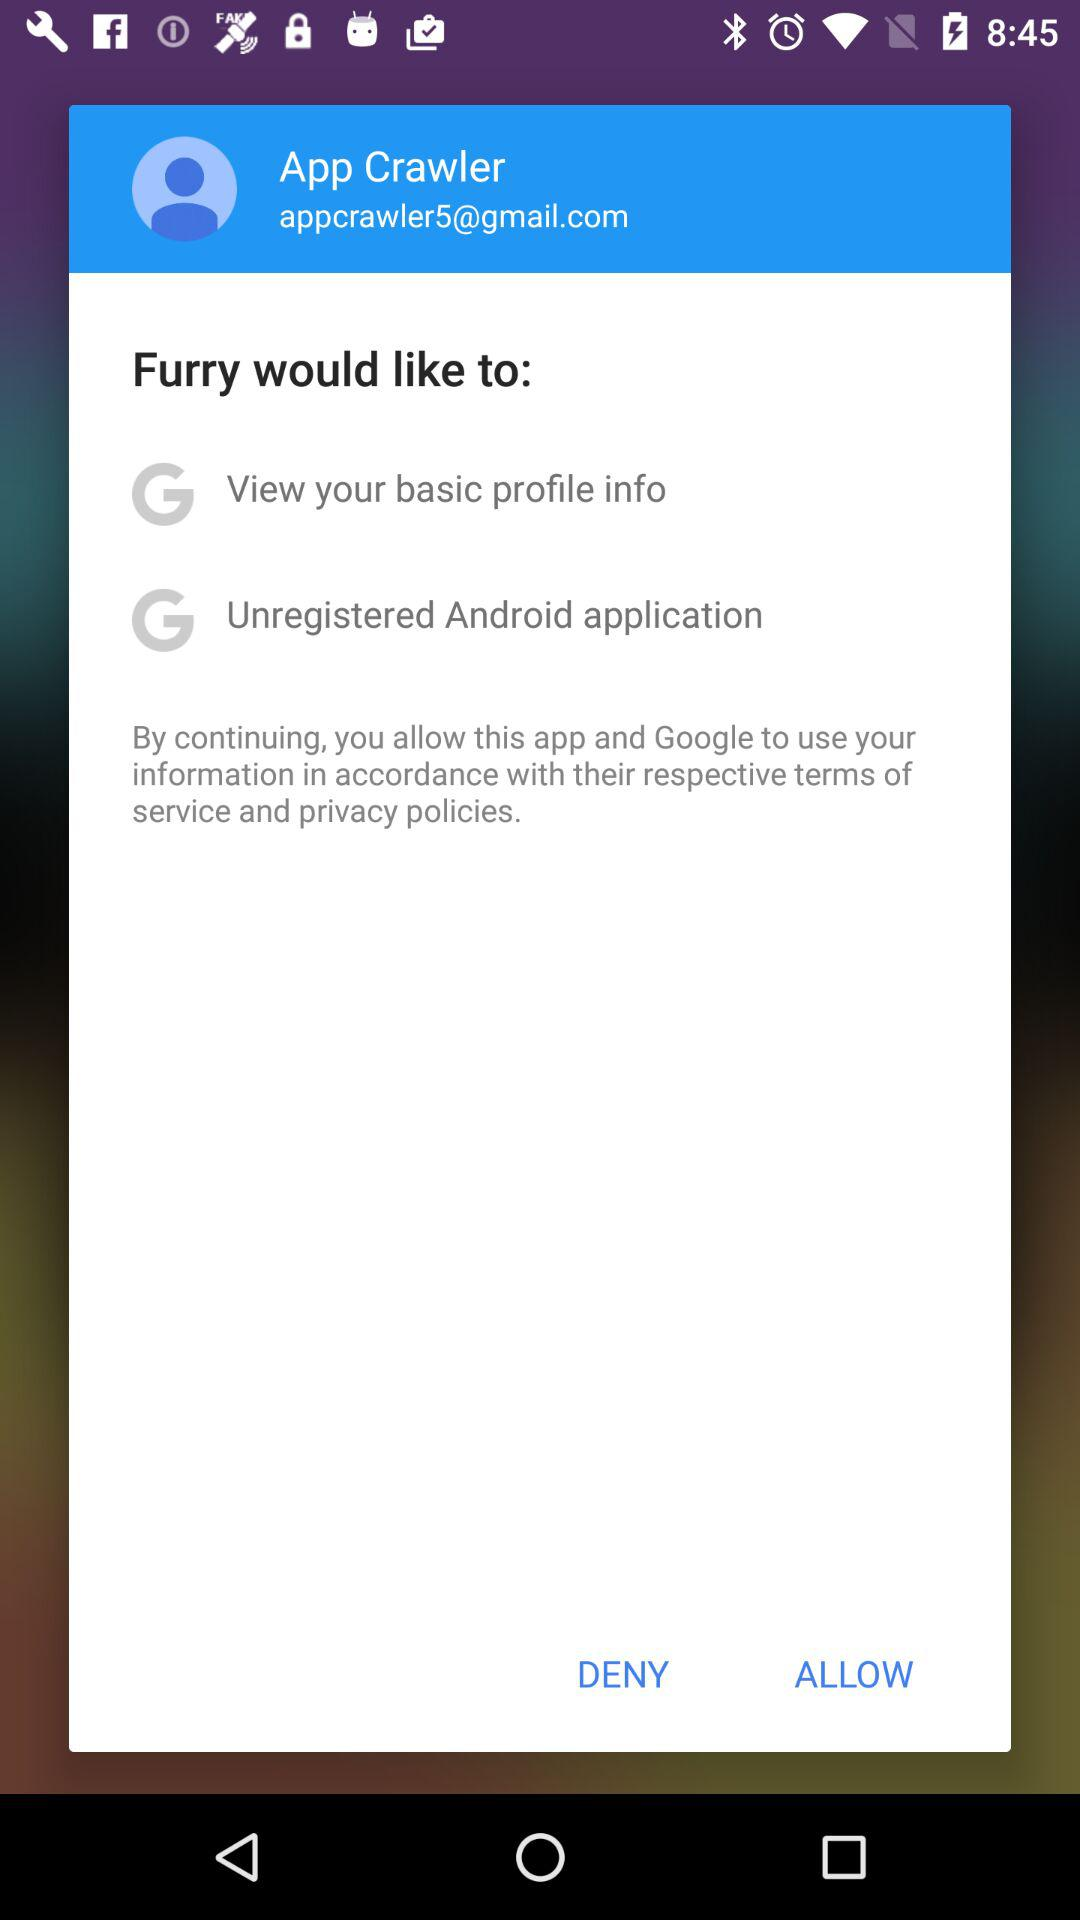What Gmail address is used? The used Gmail address is appcrawler5@gmail.com. 